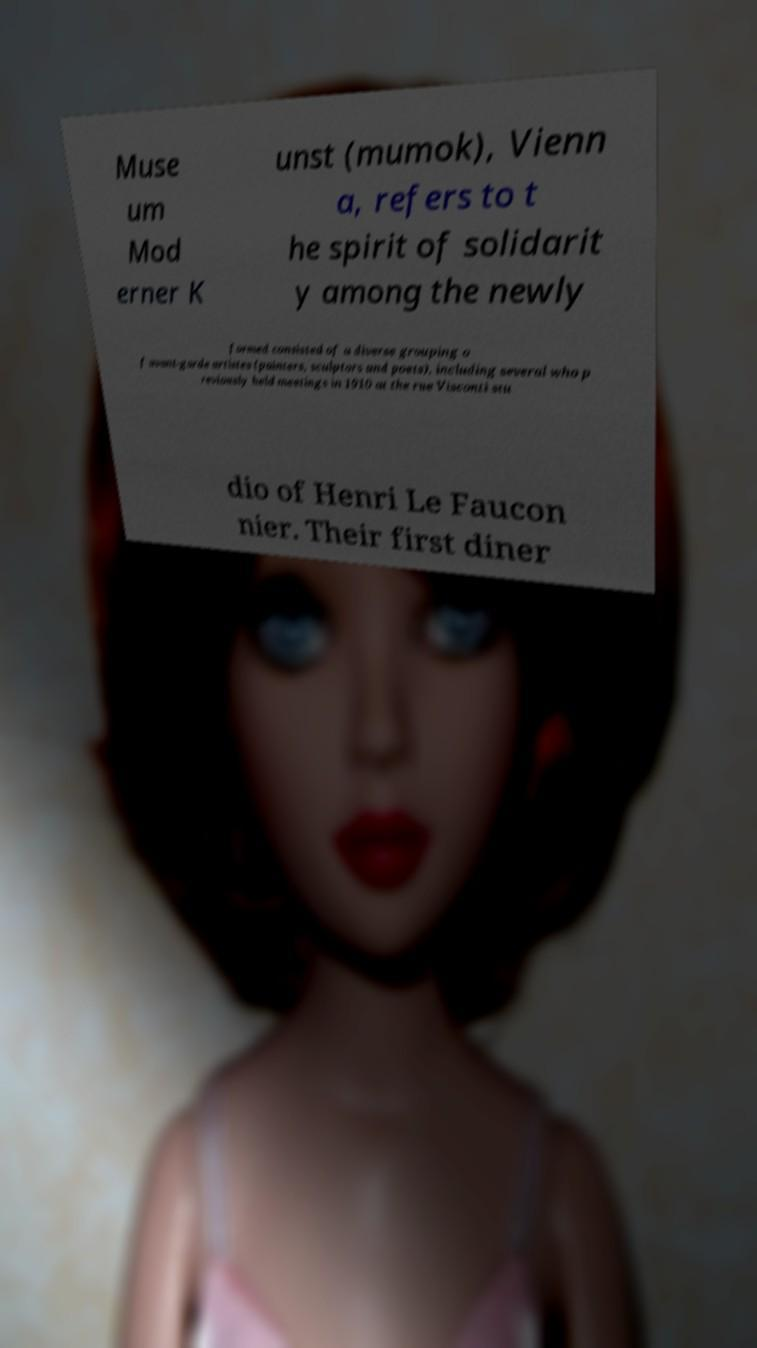Please identify and transcribe the text found in this image. Muse um Mod erner K unst (mumok), Vienn a, refers to t he spirit of solidarit y among the newly formed consisted of a diverse grouping o f avant-garde artistes (painters, sculptors and poets), including several who p reviously held meetings in 1910 at the rue Visconti stu dio of Henri Le Faucon nier. Their first diner 